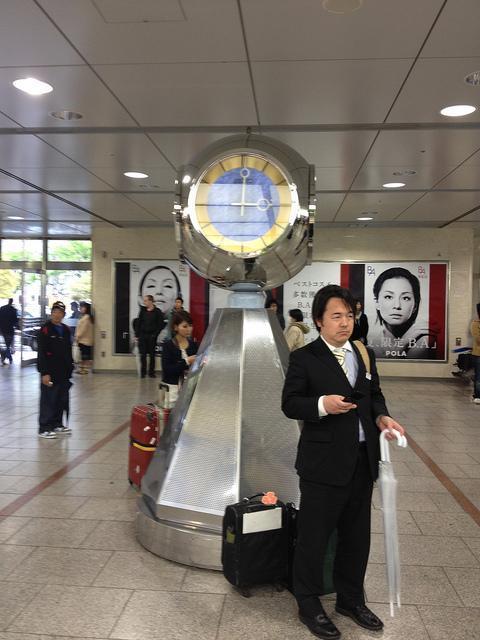How many clocks are there?
Give a very brief answer. 1. How many people can be seen?
Give a very brief answer. 2. How many suitcases can you see?
Give a very brief answer. 2. 